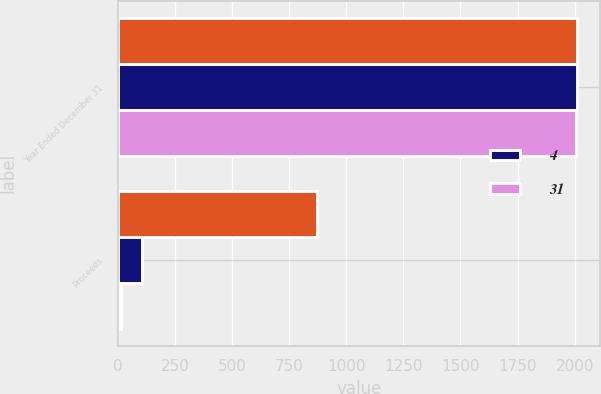Convert chart. <chart><loc_0><loc_0><loc_500><loc_500><stacked_bar_chart><ecel><fcel>Year Ended December 31<fcel>Proceeds<nl><fcel>nan<fcel>2010<fcel>871<nl><fcel>4<fcel>2009<fcel>107<nl><fcel>31<fcel>2008<fcel>14<nl></chart> 